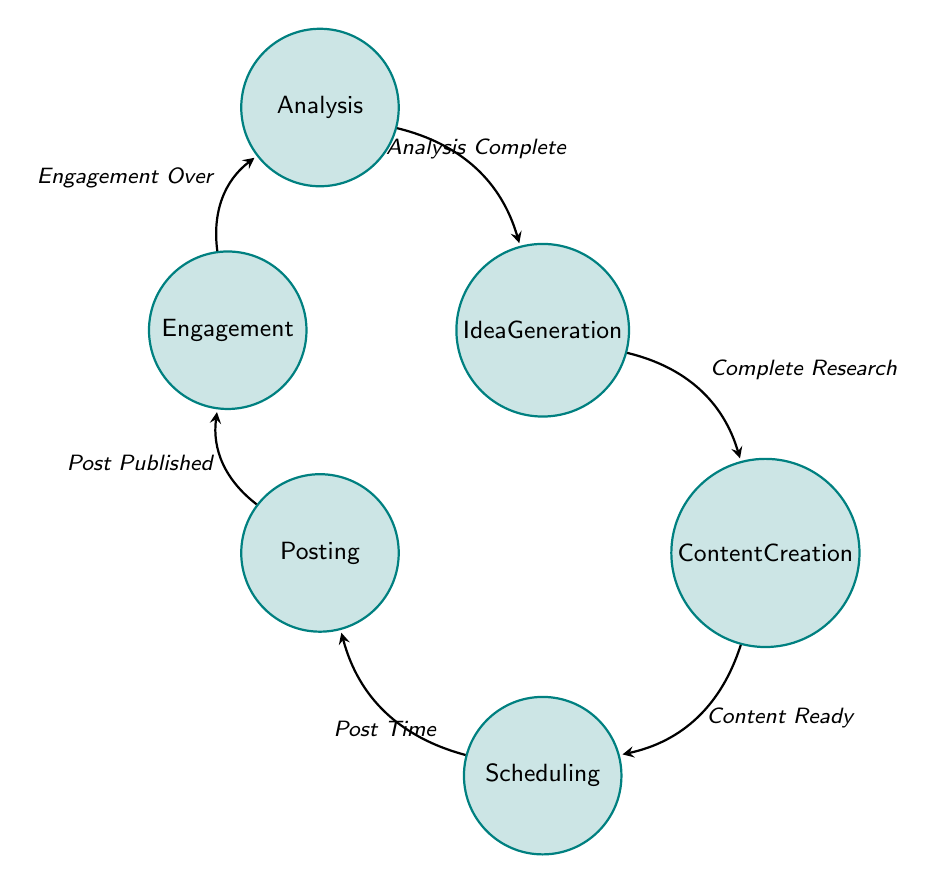What is the first state in the diagram? The diagram begins with the "Idea Generation" state, which represents the initial stage of brainstorming and gathering ideas for posts.
Answer: Idea Generation How many states are present in the diagram? The diagram contains six states: Idea Generation, Content Creation, Scheduling, Posting, Engagement, and Analysis, making a total of six states.
Answer: Six What action is required to transition from Content Creation to Scheduling? The transition between these states occurs when the action "Content Ready" is completed, indicating that the content has been created and is ready to be scheduled.
Answer: Content Ready Which state comes after Posting? After the Posting state, the diagram transitions to the Engagement state, which involves interacting with followers after content has been published.
Answer: Engagement What is the transition trigger from Engagement to Analysis? The transition between Engagement and Analysis occurs when "Engagement Over" is reached, indicating the end of the engagement period after a post.
Answer: Engagement Over How many transitions are there in total in the diagram? The diagram shows a total of six transitions: Generate to Create, Create to Schedule, Schedule to Post, Post to Engage, Engage to Analyze, and Analyze to Generate.
Answer: Six What is the last state before returning to Idea Generation? The final state before returning to Idea Generation is Analysis, which involves reviewing performance data before generating new ideas.
Answer: Analysis Which action is part of the Scheduling state? Within the Scheduling state, one of the actions taken is "Set Publish Dates", which refers to planning when the posts will go live.
Answer: Set Publish Dates What state must be completed before moving to Posting? Before transitioning to Posting, the Scheduling state must be completed, signifying that all posts have been scheduled properly for publication.
Answer: Scheduling 